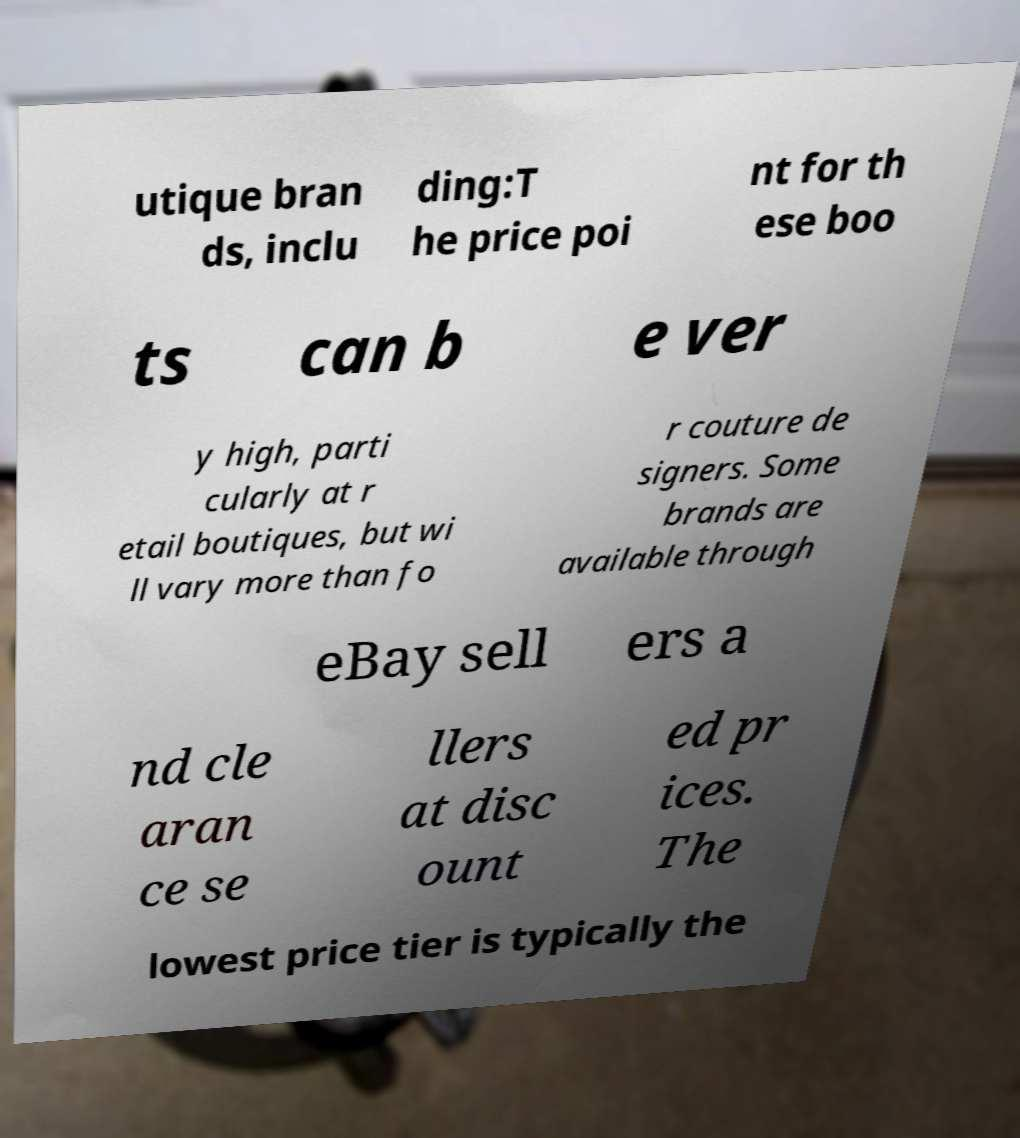Could you assist in decoding the text presented in this image and type it out clearly? utique bran ds, inclu ding:T he price poi nt for th ese boo ts can b e ver y high, parti cularly at r etail boutiques, but wi ll vary more than fo r couture de signers. Some brands are available through eBay sell ers a nd cle aran ce se llers at disc ount ed pr ices. The lowest price tier is typically the 